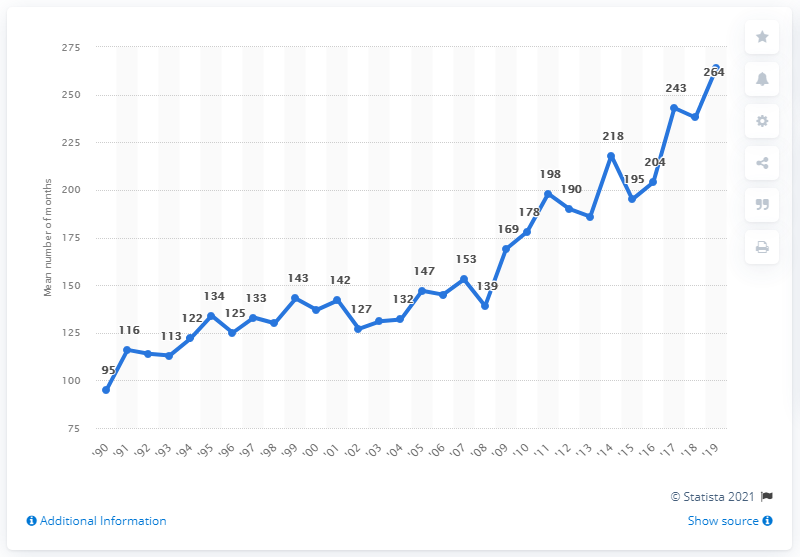Draw attention to some important aspects in this diagram. In 1990, the average number of months between sentencing and execution was 95 months. 